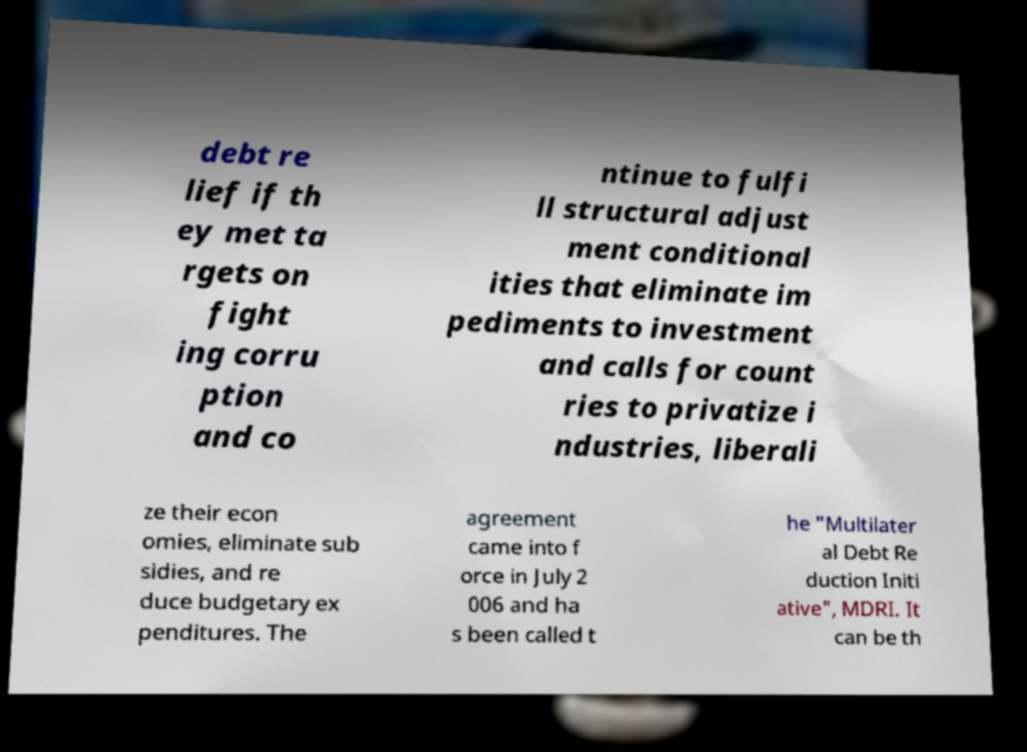I need the written content from this picture converted into text. Can you do that? debt re lief if th ey met ta rgets on fight ing corru ption and co ntinue to fulfi ll structural adjust ment conditional ities that eliminate im pediments to investment and calls for count ries to privatize i ndustries, liberali ze their econ omies, eliminate sub sidies, and re duce budgetary ex penditures. The agreement came into f orce in July 2 006 and ha s been called t he "Multilater al Debt Re duction Initi ative", MDRI. It can be th 